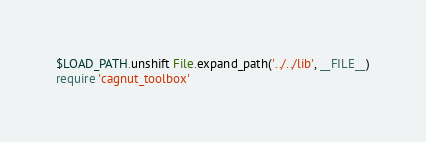Convert code to text. <code><loc_0><loc_0><loc_500><loc_500><_Ruby_>$LOAD_PATH.unshift File.expand_path('../../lib', __FILE__)
require 'cagnut_toolbox'
</code> 